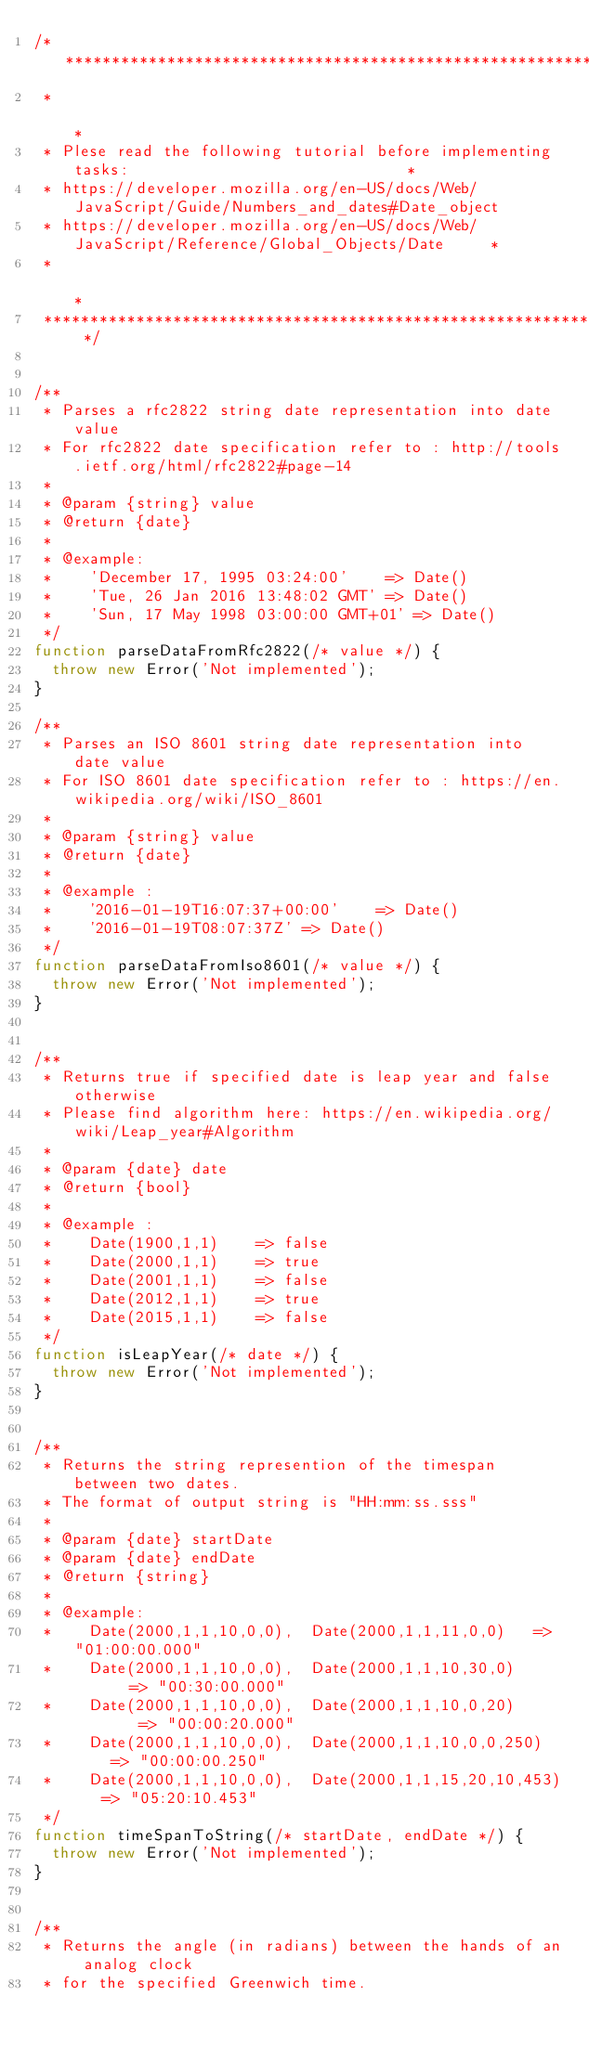Convert code to text. <code><loc_0><loc_0><loc_500><loc_500><_JavaScript_>/* *******************************************************************************************
 *                                                                                           *
 * Plese read the following tutorial before implementing tasks:                              *
 * https://developer.mozilla.org/en-US/docs/Web/JavaScript/Guide/Numbers_and_dates#Date_object
 * https://developer.mozilla.org/en-US/docs/Web/JavaScript/Reference/Global_Objects/Date     *
 *                                                                                           *
 ******************************************************************************************* */


/**
 * Parses a rfc2822 string date representation into date value
 * For rfc2822 date specification refer to : http://tools.ietf.org/html/rfc2822#page-14
 *
 * @param {string} value
 * @return {date}
 *
 * @example:
 *    'December 17, 1995 03:24:00'    => Date()
 *    'Tue, 26 Jan 2016 13:48:02 GMT' => Date()
 *    'Sun, 17 May 1998 03:00:00 GMT+01' => Date()
 */
function parseDataFromRfc2822(/* value */) {
  throw new Error('Not implemented');
}

/**
 * Parses an ISO 8601 string date representation into date value
 * For ISO 8601 date specification refer to : https://en.wikipedia.org/wiki/ISO_8601
 *
 * @param {string} value
 * @return {date}
 *
 * @example :
 *    '2016-01-19T16:07:37+00:00'    => Date()
 *    '2016-01-19T08:07:37Z' => Date()
 */
function parseDataFromIso8601(/* value */) {
  throw new Error('Not implemented');
}


/**
 * Returns true if specified date is leap year and false otherwise
 * Please find algorithm here: https://en.wikipedia.org/wiki/Leap_year#Algorithm
 *
 * @param {date} date
 * @return {bool}
 *
 * @example :
 *    Date(1900,1,1)    => false
 *    Date(2000,1,1)    => true
 *    Date(2001,1,1)    => false
 *    Date(2012,1,1)    => true
 *    Date(2015,1,1)    => false
 */
function isLeapYear(/* date */) {
  throw new Error('Not implemented');
}


/**
 * Returns the string represention of the timespan between two dates.
 * The format of output string is "HH:mm:ss.sss"
 *
 * @param {date} startDate
 * @param {date} endDate
 * @return {string}
 *
 * @example:
 *    Date(2000,1,1,10,0,0),  Date(2000,1,1,11,0,0)   => "01:00:00.000"
 *    Date(2000,1,1,10,0,0),  Date(2000,1,1,10,30,0)       => "00:30:00.000"
 *    Date(2000,1,1,10,0,0),  Date(2000,1,1,10,0,20)        => "00:00:20.000"
 *    Date(2000,1,1,10,0,0),  Date(2000,1,1,10,0,0,250)     => "00:00:00.250"
 *    Date(2000,1,1,10,0,0),  Date(2000,1,1,15,20,10,453)   => "05:20:10.453"
 */
function timeSpanToString(/* startDate, endDate */) {
  throw new Error('Not implemented');
}


/**
 * Returns the angle (in radians) between the hands of an analog clock
 * for the specified Greenwich time.</code> 